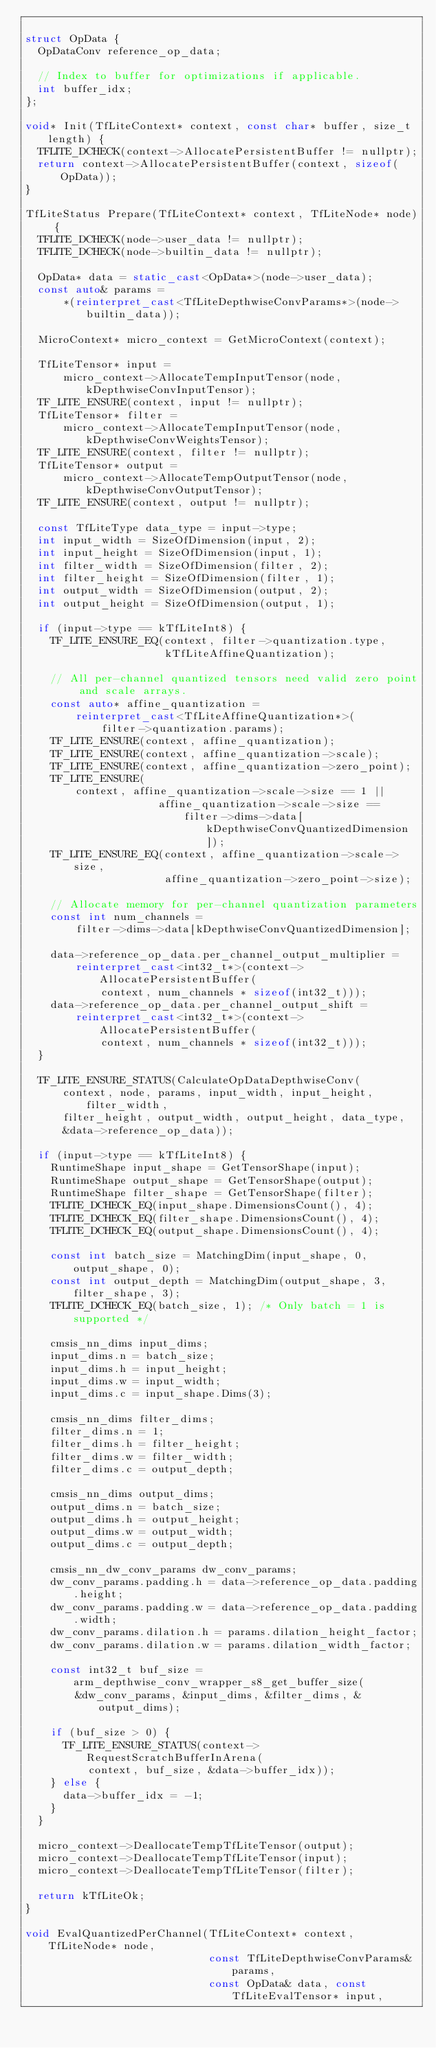Convert code to text. <code><loc_0><loc_0><loc_500><loc_500><_C++_>
struct OpData {
  OpDataConv reference_op_data;

  // Index to buffer for optimizations if applicable.
  int buffer_idx;
};

void* Init(TfLiteContext* context, const char* buffer, size_t length) {
  TFLITE_DCHECK(context->AllocatePersistentBuffer != nullptr);
  return context->AllocatePersistentBuffer(context, sizeof(OpData));
}

TfLiteStatus Prepare(TfLiteContext* context, TfLiteNode* node) {
  TFLITE_DCHECK(node->user_data != nullptr);
  TFLITE_DCHECK(node->builtin_data != nullptr);

  OpData* data = static_cast<OpData*>(node->user_data);
  const auto& params =
      *(reinterpret_cast<TfLiteDepthwiseConvParams*>(node->builtin_data));

  MicroContext* micro_context = GetMicroContext(context);

  TfLiteTensor* input =
      micro_context->AllocateTempInputTensor(node, kDepthwiseConvInputTensor);
  TF_LITE_ENSURE(context, input != nullptr);
  TfLiteTensor* filter =
      micro_context->AllocateTempInputTensor(node, kDepthwiseConvWeightsTensor);
  TF_LITE_ENSURE(context, filter != nullptr);
  TfLiteTensor* output =
      micro_context->AllocateTempOutputTensor(node, kDepthwiseConvOutputTensor);
  TF_LITE_ENSURE(context, output != nullptr);

  const TfLiteType data_type = input->type;
  int input_width = SizeOfDimension(input, 2);
  int input_height = SizeOfDimension(input, 1);
  int filter_width = SizeOfDimension(filter, 2);
  int filter_height = SizeOfDimension(filter, 1);
  int output_width = SizeOfDimension(output, 2);
  int output_height = SizeOfDimension(output, 1);

  if (input->type == kTfLiteInt8) {
    TF_LITE_ENSURE_EQ(context, filter->quantization.type,
                      kTfLiteAffineQuantization);

    // All per-channel quantized tensors need valid zero point and scale arrays.
    const auto* affine_quantization =
        reinterpret_cast<TfLiteAffineQuantization*>(
            filter->quantization.params);
    TF_LITE_ENSURE(context, affine_quantization);
    TF_LITE_ENSURE(context, affine_quantization->scale);
    TF_LITE_ENSURE(context, affine_quantization->zero_point);
    TF_LITE_ENSURE(
        context, affine_quantization->scale->size == 1 ||
                     affine_quantization->scale->size ==
                         filter->dims->data[kDepthwiseConvQuantizedDimension]);
    TF_LITE_ENSURE_EQ(context, affine_quantization->scale->size,
                      affine_quantization->zero_point->size);

    // Allocate memory for per-channel quantization parameters
    const int num_channels =
        filter->dims->data[kDepthwiseConvQuantizedDimension];

    data->reference_op_data.per_channel_output_multiplier =
        reinterpret_cast<int32_t*>(context->AllocatePersistentBuffer(
            context, num_channels * sizeof(int32_t)));
    data->reference_op_data.per_channel_output_shift =
        reinterpret_cast<int32_t*>(context->AllocatePersistentBuffer(
            context, num_channels * sizeof(int32_t)));
  }

  TF_LITE_ENSURE_STATUS(CalculateOpDataDepthwiseConv(
      context, node, params, input_width, input_height, filter_width,
      filter_height, output_width, output_height, data_type,
      &data->reference_op_data));

  if (input->type == kTfLiteInt8) {
    RuntimeShape input_shape = GetTensorShape(input);
    RuntimeShape output_shape = GetTensorShape(output);
    RuntimeShape filter_shape = GetTensorShape(filter);
    TFLITE_DCHECK_EQ(input_shape.DimensionsCount(), 4);
    TFLITE_DCHECK_EQ(filter_shape.DimensionsCount(), 4);
    TFLITE_DCHECK_EQ(output_shape.DimensionsCount(), 4);

    const int batch_size = MatchingDim(input_shape, 0, output_shape, 0);
    const int output_depth = MatchingDim(output_shape, 3, filter_shape, 3);
    TFLITE_DCHECK_EQ(batch_size, 1); /* Only batch = 1 is supported */

    cmsis_nn_dims input_dims;
    input_dims.n = batch_size;
    input_dims.h = input_height;
    input_dims.w = input_width;
    input_dims.c = input_shape.Dims(3);

    cmsis_nn_dims filter_dims;
    filter_dims.n = 1;
    filter_dims.h = filter_height;
    filter_dims.w = filter_width;
    filter_dims.c = output_depth;

    cmsis_nn_dims output_dims;
    output_dims.n = batch_size;
    output_dims.h = output_height;
    output_dims.w = output_width;
    output_dims.c = output_depth;

    cmsis_nn_dw_conv_params dw_conv_params;
    dw_conv_params.padding.h = data->reference_op_data.padding.height;
    dw_conv_params.padding.w = data->reference_op_data.padding.width;
    dw_conv_params.dilation.h = params.dilation_height_factor;
    dw_conv_params.dilation.w = params.dilation_width_factor;

    const int32_t buf_size = arm_depthwise_conv_wrapper_s8_get_buffer_size(
        &dw_conv_params, &input_dims, &filter_dims, &output_dims);

    if (buf_size > 0) {
      TF_LITE_ENSURE_STATUS(context->RequestScratchBufferInArena(
          context, buf_size, &data->buffer_idx));
    } else {
      data->buffer_idx = -1;
    }
  }

  micro_context->DeallocateTempTfLiteTensor(output);
  micro_context->DeallocateTempTfLiteTensor(input);
  micro_context->DeallocateTempTfLiteTensor(filter);

  return kTfLiteOk;
}

void EvalQuantizedPerChannel(TfLiteContext* context, TfLiteNode* node,
                             const TfLiteDepthwiseConvParams& params,
                             const OpData& data, const TfLiteEvalTensor* input,</code> 